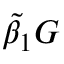Convert formula to latex. <formula><loc_0><loc_0><loc_500><loc_500>\tilde { \beta } _ { 1 } G</formula> 